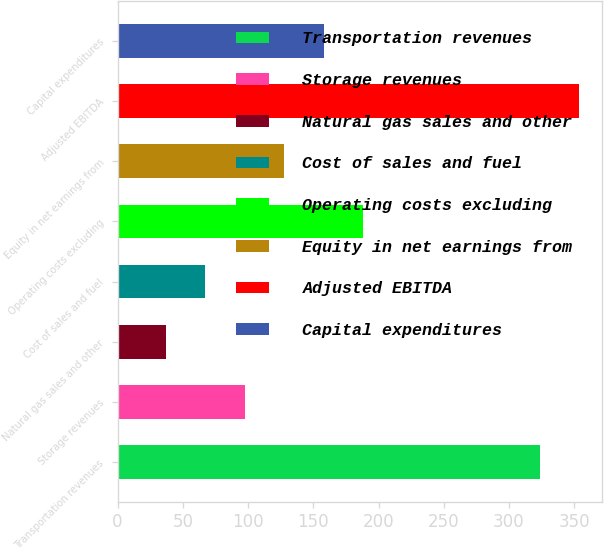Convert chart to OTSL. <chart><loc_0><loc_0><loc_500><loc_500><bar_chart><fcel>Transportation revenues<fcel>Storage revenues<fcel>Natural gas sales and other<fcel>Cost of sales and fuel<fcel>Operating costs excluding<fcel>Equity in net earnings from<fcel>Adjusted EBITDA<fcel>Capital expenditures<nl><fcel>323.7<fcel>97.56<fcel>37<fcel>67.28<fcel>188.4<fcel>127.84<fcel>353.98<fcel>158.12<nl></chart> 